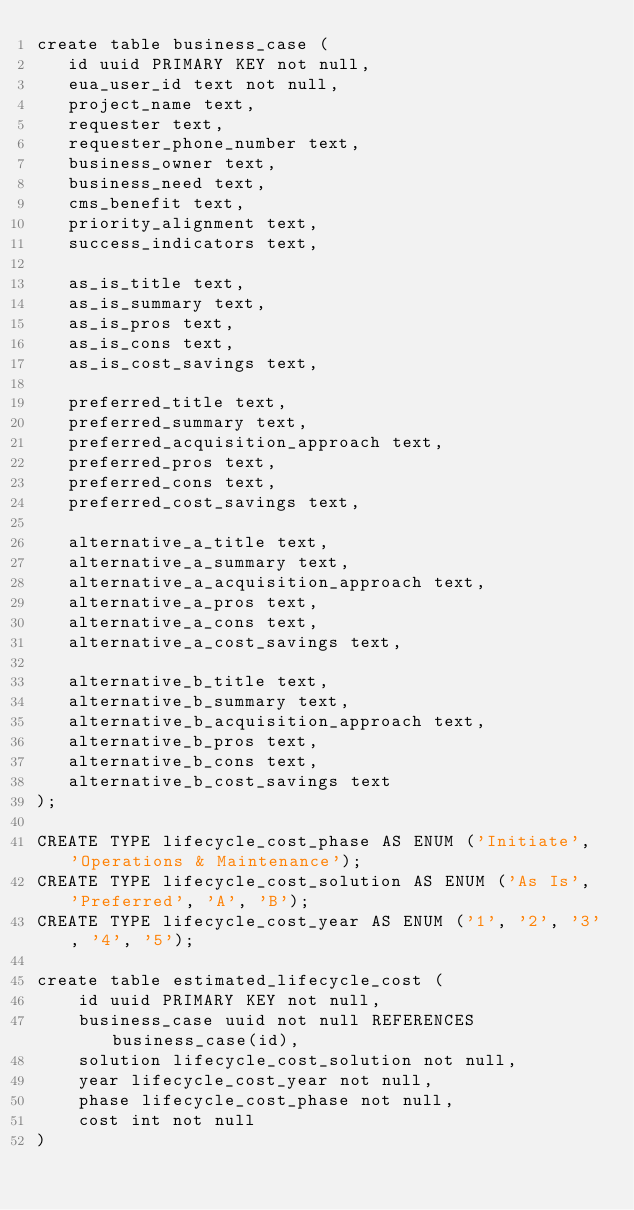<code> <loc_0><loc_0><loc_500><loc_500><_SQL_>create table business_case (
   id uuid PRIMARY KEY not null,
   eua_user_id text not null,
   project_name text,
   requester text,
   requester_phone_number text,
   business_owner text,
   business_need text,
   cms_benefit text,
   priority_alignment text,
   success_indicators text,

   as_is_title text,
   as_is_summary text,
   as_is_pros text,
   as_is_cons text,
   as_is_cost_savings text,

   preferred_title text,
   preferred_summary text,
   preferred_acquisition_approach text,
   preferred_pros text,
   preferred_cons text,
   preferred_cost_savings text,

   alternative_a_title text,
   alternative_a_summary text,
   alternative_a_acquisition_approach text,
   alternative_a_pros text,
   alternative_a_cons text,
   alternative_a_cost_savings text,

   alternative_b_title text,
   alternative_b_summary text,
   alternative_b_acquisition_approach text,
   alternative_b_pros text,
   alternative_b_cons text,
   alternative_b_cost_savings text
);

CREATE TYPE lifecycle_cost_phase AS ENUM ('Initiate', 'Operations & Maintenance');
CREATE TYPE lifecycle_cost_solution AS ENUM ('As Is', 'Preferred', 'A', 'B');
CREATE TYPE lifecycle_cost_year AS ENUM ('1', '2', '3', '4', '5');

create table estimated_lifecycle_cost (
    id uuid PRIMARY KEY not null,
    business_case uuid not null REFERENCES business_case(id),
    solution lifecycle_cost_solution not null,
    year lifecycle_cost_year not null,
    phase lifecycle_cost_phase not null,
    cost int not null
)
</code> 